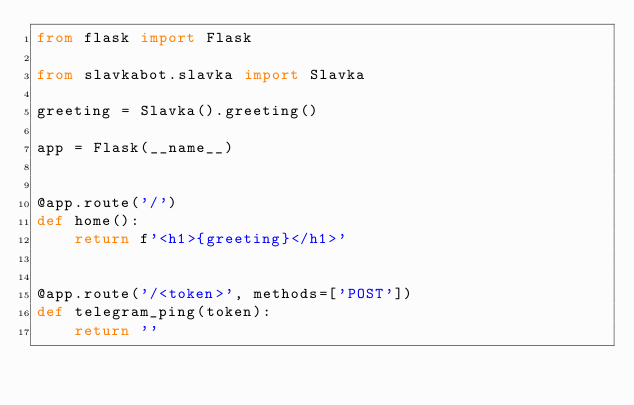<code> <loc_0><loc_0><loc_500><loc_500><_Python_>from flask import Flask

from slavkabot.slavka import Slavka

greeting = Slavka().greeting()

app = Flask(__name__)


@app.route('/')
def home():
    return f'<h1>{greeting}</h1>'


@app.route('/<token>', methods=['POST'])
def telegram_ping(token):
    return ''
</code> 